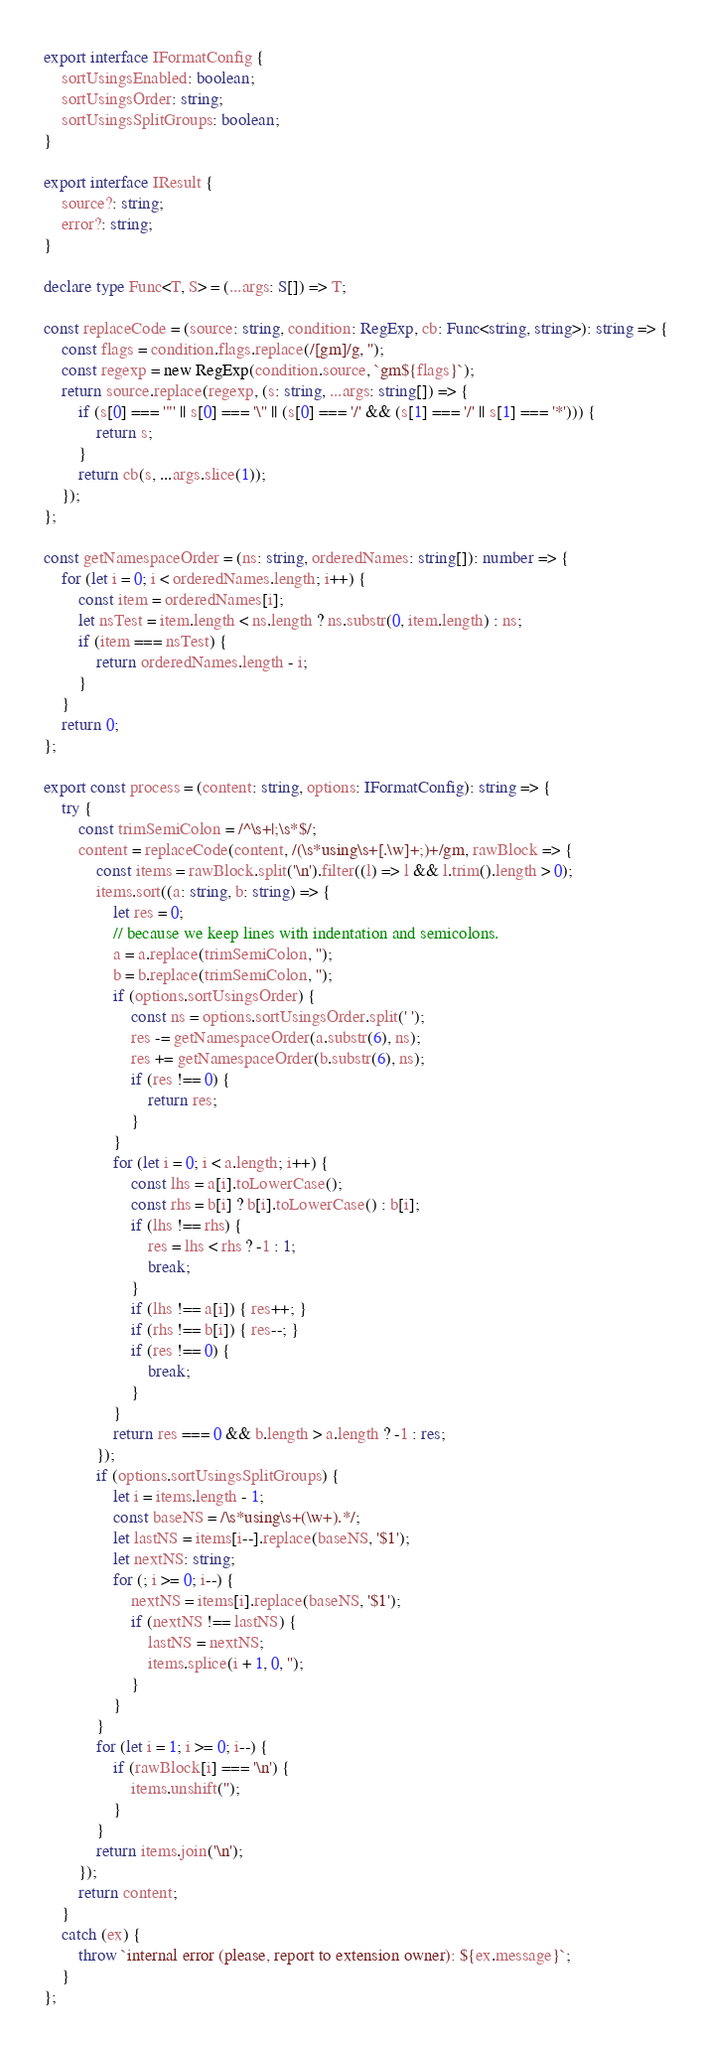Convert code to text. <code><loc_0><loc_0><loc_500><loc_500><_TypeScript_>export interface IFormatConfig {
    sortUsingsEnabled: boolean;
    sortUsingsOrder: string;
    sortUsingsSplitGroups: boolean;
}

export interface IResult {
    source?: string;
    error?: string;
}

declare type Func<T, S> = (...args: S[]) => T;

const replaceCode = (source: string, condition: RegExp, cb: Func<string, string>): string => {
    const flags = condition.flags.replace(/[gm]/g, '');
    const regexp = new RegExp(condition.source, `gm${flags}`);
    return source.replace(regexp, (s: string, ...args: string[]) => {
        if (s[0] === '"' || s[0] === '\'' || (s[0] === '/' && (s[1] === '/' || s[1] === '*'))) {
            return s;
        }
        return cb(s, ...args.slice(1));
    });
};

const getNamespaceOrder = (ns: string, orderedNames: string[]): number => {
    for (let i = 0; i < orderedNames.length; i++) {
        const item = orderedNames[i];
        let nsTest = item.length < ns.length ? ns.substr(0, item.length) : ns;
        if (item === nsTest) {
            return orderedNames.length - i;
        }
    }
    return 0;
};

export const process = (content: string, options: IFormatConfig): string => {
    try {
        const trimSemiColon = /^\s+|;\s*$/;
        content = replaceCode(content, /(\s*using\s+[.\w]+;)+/gm, rawBlock => {
            const items = rawBlock.split('\n').filter((l) => l && l.trim().length > 0);
            items.sort((a: string, b: string) => {
                let res = 0;
                // because we keep lines with indentation and semicolons.
                a = a.replace(trimSemiColon, '');
                b = b.replace(trimSemiColon, '');
                if (options.sortUsingsOrder) {
                    const ns = options.sortUsingsOrder.split(' ');
                    res -= getNamespaceOrder(a.substr(6), ns);
                    res += getNamespaceOrder(b.substr(6), ns);
                    if (res !== 0) {
                        return res;
                    }
                }
                for (let i = 0; i < a.length; i++) {
                    const lhs = a[i].toLowerCase();
                    const rhs = b[i] ? b[i].toLowerCase() : b[i];
                    if (lhs !== rhs) {
                        res = lhs < rhs ? -1 : 1;
                        break;
                    }
                    if (lhs !== a[i]) { res++; }
                    if (rhs !== b[i]) { res--; }
                    if (res !== 0) {
                        break;
                    }
                }
                return res === 0 && b.length > a.length ? -1 : res;
            });
            if (options.sortUsingsSplitGroups) {
                let i = items.length - 1;
                const baseNS = /\s*using\s+(\w+).*/;
                let lastNS = items[i--].replace(baseNS, '$1');
                let nextNS: string;
                for (; i >= 0; i--) {
                    nextNS = items[i].replace(baseNS, '$1');
                    if (nextNS !== lastNS) {
                        lastNS = nextNS;
                        items.splice(i + 1, 0, '');
                    }
                }
            }
            for (let i = 1; i >= 0; i--) {
                if (rawBlock[i] === '\n') {
                    items.unshift('');
                }
            }
            return items.join('\n');
        });
        return content;
    }
    catch (ex) {
        throw `internal error (please, report to extension owner): ${ex.message}`;
    }
};
</code> 